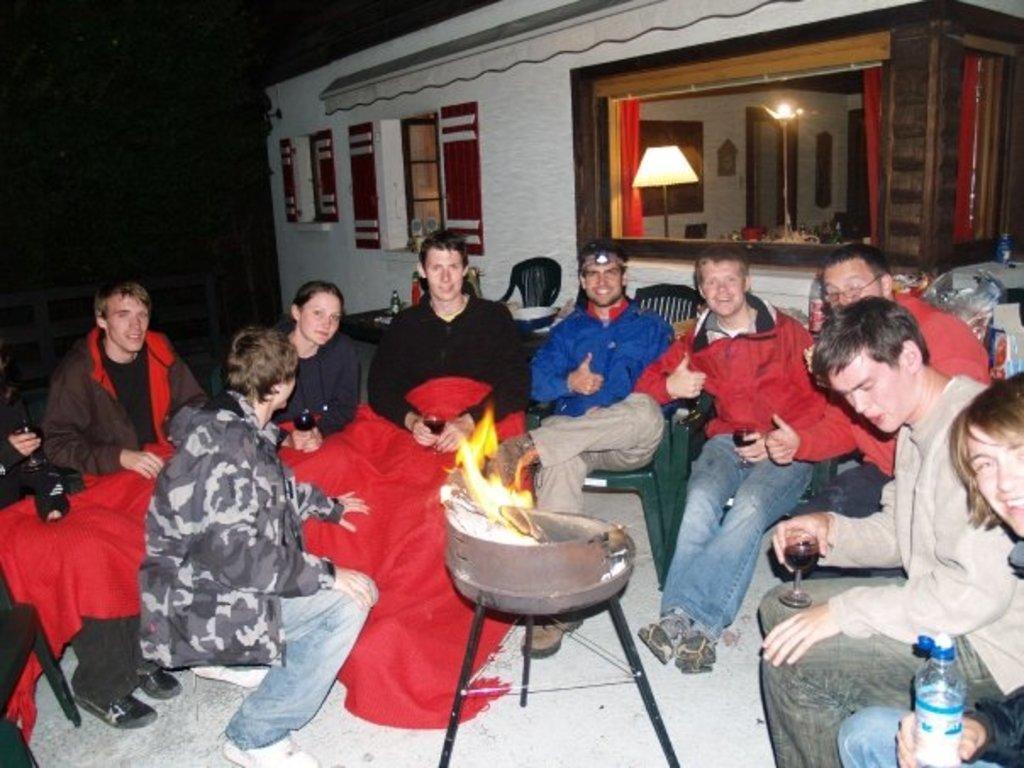In one or two sentences, can you explain what this image depicts? In this image, we can see people wearing coats and sitting on the chairs and there is a cloth and some of them are holding glasses which are containing drink and one of them is holding a bottle and we can see a fire stand. In the background, there is a shed and we can see a mirror, through the glass and we can see some lights and some other objects. 